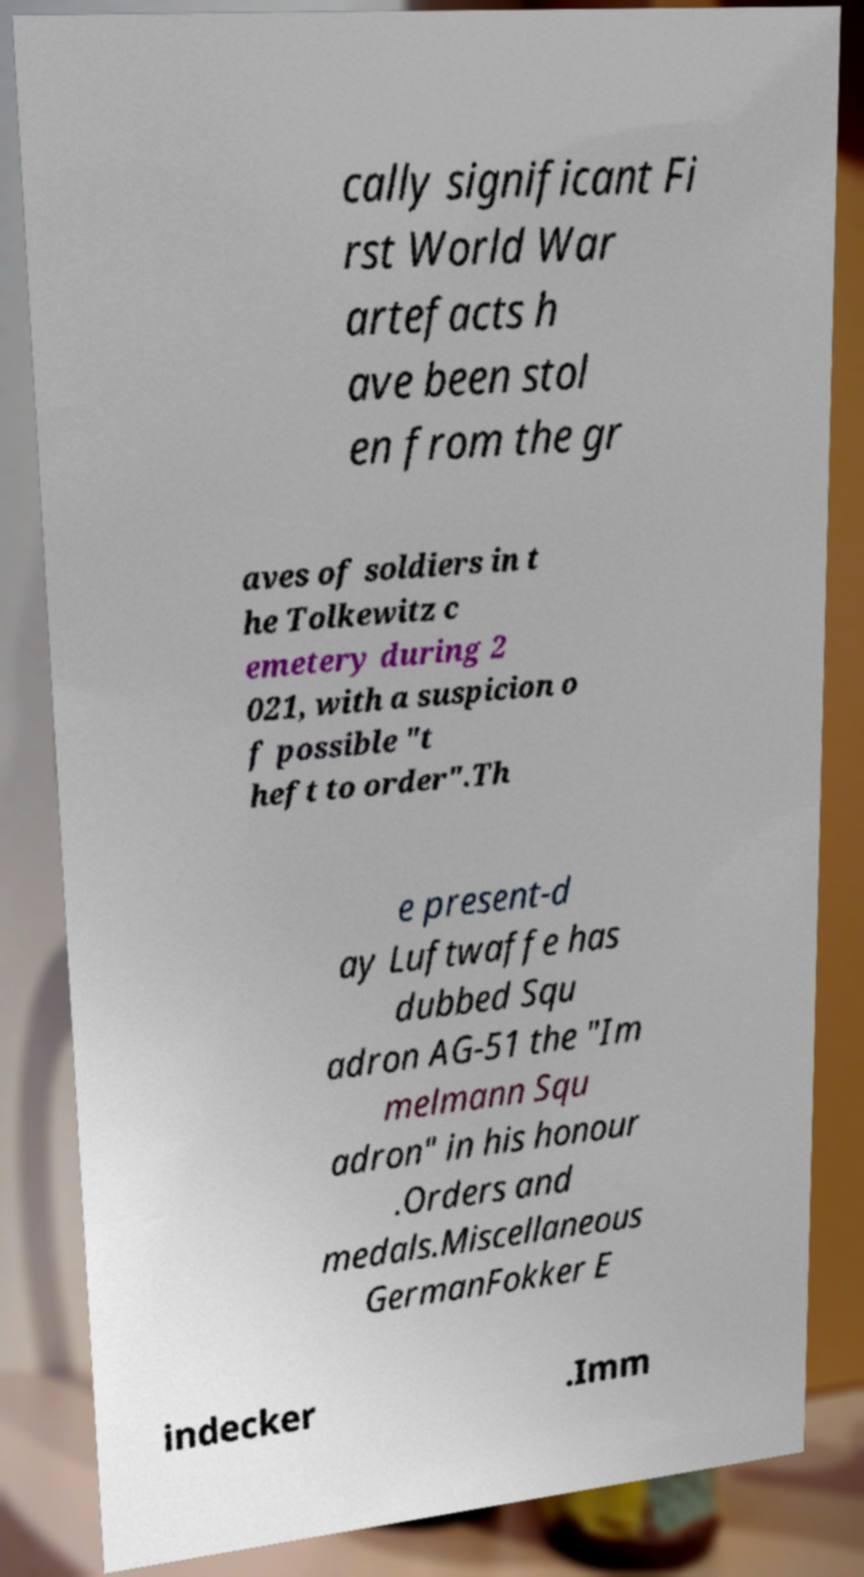Please identify and transcribe the text found in this image. cally significant Fi rst World War artefacts h ave been stol en from the gr aves of soldiers in t he Tolkewitz c emetery during 2 021, with a suspicion o f possible "t heft to order".Th e present-d ay Luftwaffe has dubbed Squ adron AG-51 the "Im melmann Squ adron" in his honour .Orders and medals.Miscellaneous GermanFokker E indecker .Imm 